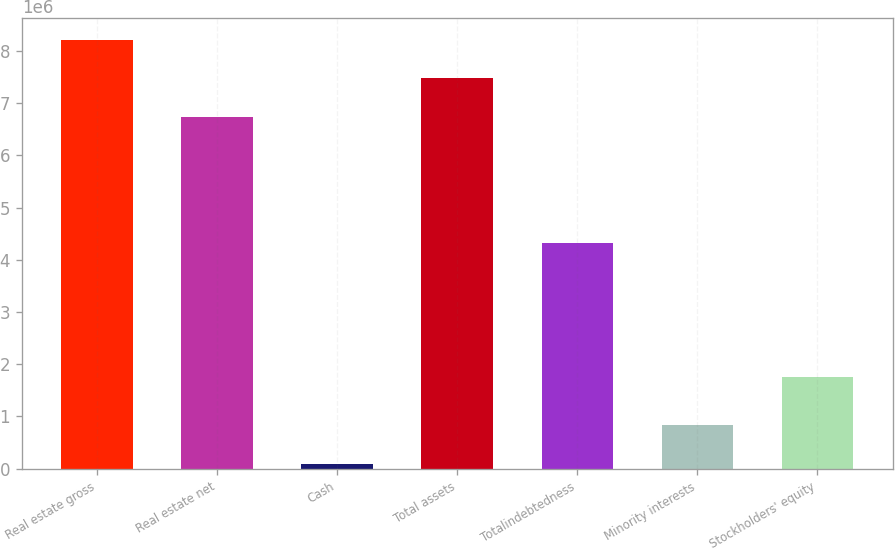Convert chart. <chart><loc_0><loc_0><loc_500><loc_500><bar_chart><fcel>Real estate gross<fcel>Real estate net<fcel>Cash<fcel>Total assets<fcel>Totalindebtedness<fcel>Minority interests<fcel>Stockholders' equity<nl><fcel>8.21002e+06<fcel>6.73805e+06<fcel>98067<fcel>7.47404e+06<fcel>4.31494e+06<fcel>844740<fcel>1.75407e+06<nl></chart> 